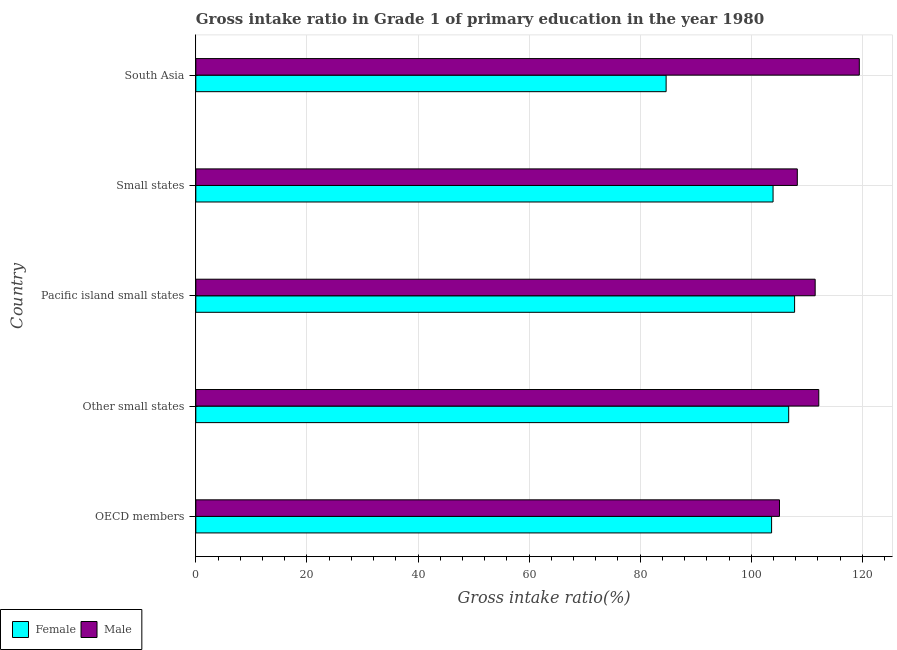How many different coloured bars are there?
Your answer should be very brief. 2. How many groups of bars are there?
Make the answer very short. 5. How many bars are there on the 2nd tick from the top?
Your answer should be compact. 2. How many bars are there on the 1st tick from the bottom?
Make the answer very short. 2. In how many cases, is the number of bars for a given country not equal to the number of legend labels?
Provide a short and direct response. 0. What is the gross intake ratio(female) in South Asia?
Your response must be concise. 84.67. Across all countries, what is the maximum gross intake ratio(male)?
Keep it short and to the point. 119.46. Across all countries, what is the minimum gross intake ratio(male)?
Provide a short and direct response. 105.08. In which country was the gross intake ratio(female) maximum?
Offer a terse response. Pacific island small states. What is the total gross intake ratio(male) in the graph?
Ensure brevity in your answer.  556.5. What is the difference between the gross intake ratio(female) in Other small states and that in South Asia?
Make the answer very short. 22.07. What is the difference between the gross intake ratio(female) in South Asia and the gross intake ratio(male) in Small states?
Provide a succinct answer. -23.62. What is the average gross intake ratio(female) per country?
Your answer should be compact. 101.36. What is the difference between the gross intake ratio(male) and gross intake ratio(female) in South Asia?
Your answer should be compact. 34.78. What is the ratio of the gross intake ratio(female) in OECD members to that in Small states?
Ensure brevity in your answer.  1. Is the gross intake ratio(female) in Other small states less than that in South Asia?
Offer a very short reply. No. Is the difference between the gross intake ratio(male) in OECD members and Other small states greater than the difference between the gross intake ratio(female) in OECD members and Other small states?
Offer a terse response. No. What is the difference between the highest and the second highest gross intake ratio(male)?
Ensure brevity in your answer.  7.3. What is the difference between the highest and the lowest gross intake ratio(male)?
Your response must be concise. 14.37. In how many countries, is the gross intake ratio(male) greater than the average gross intake ratio(male) taken over all countries?
Provide a short and direct response. 3. Are all the bars in the graph horizontal?
Give a very brief answer. Yes. How many countries are there in the graph?
Ensure brevity in your answer.  5. What is the difference between two consecutive major ticks on the X-axis?
Provide a short and direct response. 20. Where does the legend appear in the graph?
Offer a terse response. Bottom left. How many legend labels are there?
Make the answer very short. 2. How are the legend labels stacked?
Offer a terse response. Horizontal. What is the title of the graph?
Ensure brevity in your answer.  Gross intake ratio in Grade 1 of primary education in the year 1980. What is the label or title of the X-axis?
Your answer should be very brief. Gross intake ratio(%). What is the label or title of the Y-axis?
Make the answer very short. Country. What is the Gross intake ratio(%) in Female in OECD members?
Provide a succinct answer. 103.66. What is the Gross intake ratio(%) of Male in OECD members?
Make the answer very short. 105.08. What is the Gross intake ratio(%) of Female in Other small states?
Your answer should be compact. 106.74. What is the Gross intake ratio(%) in Male in Other small states?
Ensure brevity in your answer.  112.16. What is the Gross intake ratio(%) of Female in Pacific island small states?
Keep it short and to the point. 107.8. What is the Gross intake ratio(%) of Male in Pacific island small states?
Your answer should be very brief. 111.51. What is the Gross intake ratio(%) in Female in Small states?
Provide a succinct answer. 103.93. What is the Gross intake ratio(%) in Male in Small states?
Your answer should be compact. 108.29. What is the Gross intake ratio(%) in Female in South Asia?
Your answer should be very brief. 84.67. What is the Gross intake ratio(%) in Male in South Asia?
Keep it short and to the point. 119.46. Across all countries, what is the maximum Gross intake ratio(%) in Female?
Your answer should be compact. 107.8. Across all countries, what is the maximum Gross intake ratio(%) in Male?
Offer a very short reply. 119.46. Across all countries, what is the minimum Gross intake ratio(%) in Female?
Give a very brief answer. 84.67. Across all countries, what is the minimum Gross intake ratio(%) of Male?
Your answer should be compact. 105.08. What is the total Gross intake ratio(%) of Female in the graph?
Offer a terse response. 506.8. What is the total Gross intake ratio(%) of Male in the graph?
Ensure brevity in your answer.  556.5. What is the difference between the Gross intake ratio(%) of Female in OECD members and that in Other small states?
Keep it short and to the point. -3.08. What is the difference between the Gross intake ratio(%) of Male in OECD members and that in Other small states?
Make the answer very short. -7.08. What is the difference between the Gross intake ratio(%) in Female in OECD members and that in Pacific island small states?
Ensure brevity in your answer.  -4.14. What is the difference between the Gross intake ratio(%) of Male in OECD members and that in Pacific island small states?
Your answer should be very brief. -6.42. What is the difference between the Gross intake ratio(%) of Female in OECD members and that in Small states?
Your response must be concise. -0.26. What is the difference between the Gross intake ratio(%) of Male in OECD members and that in Small states?
Your answer should be compact. -3.21. What is the difference between the Gross intake ratio(%) of Female in OECD members and that in South Asia?
Ensure brevity in your answer.  18.99. What is the difference between the Gross intake ratio(%) in Male in OECD members and that in South Asia?
Your answer should be very brief. -14.37. What is the difference between the Gross intake ratio(%) in Female in Other small states and that in Pacific island small states?
Make the answer very short. -1.06. What is the difference between the Gross intake ratio(%) of Male in Other small states and that in Pacific island small states?
Give a very brief answer. 0.65. What is the difference between the Gross intake ratio(%) of Female in Other small states and that in Small states?
Ensure brevity in your answer.  2.81. What is the difference between the Gross intake ratio(%) in Male in Other small states and that in Small states?
Offer a terse response. 3.87. What is the difference between the Gross intake ratio(%) in Female in Other small states and that in South Asia?
Provide a succinct answer. 22.07. What is the difference between the Gross intake ratio(%) of Male in Other small states and that in South Asia?
Your response must be concise. -7.3. What is the difference between the Gross intake ratio(%) of Female in Pacific island small states and that in Small states?
Ensure brevity in your answer.  3.88. What is the difference between the Gross intake ratio(%) of Male in Pacific island small states and that in Small states?
Your response must be concise. 3.21. What is the difference between the Gross intake ratio(%) of Female in Pacific island small states and that in South Asia?
Provide a succinct answer. 23.13. What is the difference between the Gross intake ratio(%) of Male in Pacific island small states and that in South Asia?
Offer a very short reply. -7.95. What is the difference between the Gross intake ratio(%) of Female in Small states and that in South Asia?
Make the answer very short. 19.25. What is the difference between the Gross intake ratio(%) in Male in Small states and that in South Asia?
Your response must be concise. -11.16. What is the difference between the Gross intake ratio(%) of Female in OECD members and the Gross intake ratio(%) of Male in Other small states?
Your response must be concise. -8.5. What is the difference between the Gross intake ratio(%) of Female in OECD members and the Gross intake ratio(%) of Male in Pacific island small states?
Ensure brevity in your answer.  -7.84. What is the difference between the Gross intake ratio(%) in Female in OECD members and the Gross intake ratio(%) in Male in Small states?
Your answer should be very brief. -4.63. What is the difference between the Gross intake ratio(%) in Female in OECD members and the Gross intake ratio(%) in Male in South Asia?
Make the answer very short. -15.79. What is the difference between the Gross intake ratio(%) of Female in Other small states and the Gross intake ratio(%) of Male in Pacific island small states?
Give a very brief answer. -4.77. What is the difference between the Gross intake ratio(%) of Female in Other small states and the Gross intake ratio(%) of Male in Small states?
Ensure brevity in your answer.  -1.55. What is the difference between the Gross intake ratio(%) in Female in Other small states and the Gross intake ratio(%) in Male in South Asia?
Your answer should be very brief. -12.72. What is the difference between the Gross intake ratio(%) of Female in Pacific island small states and the Gross intake ratio(%) of Male in Small states?
Your response must be concise. -0.49. What is the difference between the Gross intake ratio(%) in Female in Pacific island small states and the Gross intake ratio(%) in Male in South Asia?
Offer a very short reply. -11.65. What is the difference between the Gross intake ratio(%) of Female in Small states and the Gross intake ratio(%) of Male in South Asia?
Your answer should be compact. -15.53. What is the average Gross intake ratio(%) of Female per country?
Your answer should be very brief. 101.36. What is the average Gross intake ratio(%) in Male per country?
Offer a very short reply. 111.3. What is the difference between the Gross intake ratio(%) in Female and Gross intake ratio(%) in Male in OECD members?
Keep it short and to the point. -1.42. What is the difference between the Gross intake ratio(%) of Female and Gross intake ratio(%) of Male in Other small states?
Keep it short and to the point. -5.42. What is the difference between the Gross intake ratio(%) in Female and Gross intake ratio(%) in Male in Pacific island small states?
Your answer should be compact. -3.7. What is the difference between the Gross intake ratio(%) in Female and Gross intake ratio(%) in Male in Small states?
Provide a short and direct response. -4.37. What is the difference between the Gross intake ratio(%) of Female and Gross intake ratio(%) of Male in South Asia?
Your answer should be compact. -34.78. What is the ratio of the Gross intake ratio(%) in Female in OECD members to that in Other small states?
Your answer should be compact. 0.97. What is the ratio of the Gross intake ratio(%) in Male in OECD members to that in Other small states?
Provide a short and direct response. 0.94. What is the ratio of the Gross intake ratio(%) of Female in OECD members to that in Pacific island small states?
Offer a very short reply. 0.96. What is the ratio of the Gross intake ratio(%) of Male in OECD members to that in Pacific island small states?
Provide a succinct answer. 0.94. What is the ratio of the Gross intake ratio(%) of Female in OECD members to that in Small states?
Your answer should be compact. 1. What is the ratio of the Gross intake ratio(%) of Male in OECD members to that in Small states?
Keep it short and to the point. 0.97. What is the ratio of the Gross intake ratio(%) in Female in OECD members to that in South Asia?
Keep it short and to the point. 1.22. What is the ratio of the Gross intake ratio(%) of Male in OECD members to that in South Asia?
Provide a short and direct response. 0.88. What is the ratio of the Gross intake ratio(%) of Male in Other small states to that in Pacific island small states?
Your answer should be very brief. 1.01. What is the ratio of the Gross intake ratio(%) in Female in Other small states to that in Small states?
Ensure brevity in your answer.  1.03. What is the ratio of the Gross intake ratio(%) of Male in Other small states to that in Small states?
Your answer should be very brief. 1.04. What is the ratio of the Gross intake ratio(%) in Female in Other small states to that in South Asia?
Offer a terse response. 1.26. What is the ratio of the Gross intake ratio(%) in Male in Other small states to that in South Asia?
Your answer should be very brief. 0.94. What is the ratio of the Gross intake ratio(%) in Female in Pacific island small states to that in Small states?
Offer a very short reply. 1.04. What is the ratio of the Gross intake ratio(%) in Male in Pacific island small states to that in Small states?
Your response must be concise. 1.03. What is the ratio of the Gross intake ratio(%) of Female in Pacific island small states to that in South Asia?
Give a very brief answer. 1.27. What is the ratio of the Gross intake ratio(%) in Male in Pacific island small states to that in South Asia?
Your answer should be very brief. 0.93. What is the ratio of the Gross intake ratio(%) of Female in Small states to that in South Asia?
Your answer should be compact. 1.23. What is the ratio of the Gross intake ratio(%) of Male in Small states to that in South Asia?
Your response must be concise. 0.91. What is the difference between the highest and the second highest Gross intake ratio(%) in Female?
Your answer should be compact. 1.06. What is the difference between the highest and the second highest Gross intake ratio(%) in Male?
Your response must be concise. 7.3. What is the difference between the highest and the lowest Gross intake ratio(%) of Female?
Give a very brief answer. 23.13. What is the difference between the highest and the lowest Gross intake ratio(%) in Male?
Make the answer very short. 14.37. 